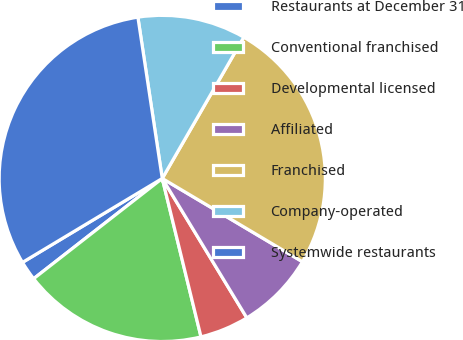<chart> <loc_0><loc_0><loc_500><loc_500><pie_chart><fcel>Restaurants at December 31<fcel>Conventional franchised<fcel>Developmental licensed<fcel>Affiliated<fcel>Franchised<fcel>Company-operated<fcel>Systemwide restaurants<nl><fcel>1.93%<fcel>18.28%<fcel>4.86%<fcel>7.79%<fcel>25.2%<fcel>10.72%<fcel>31.22%<nl></chart> 